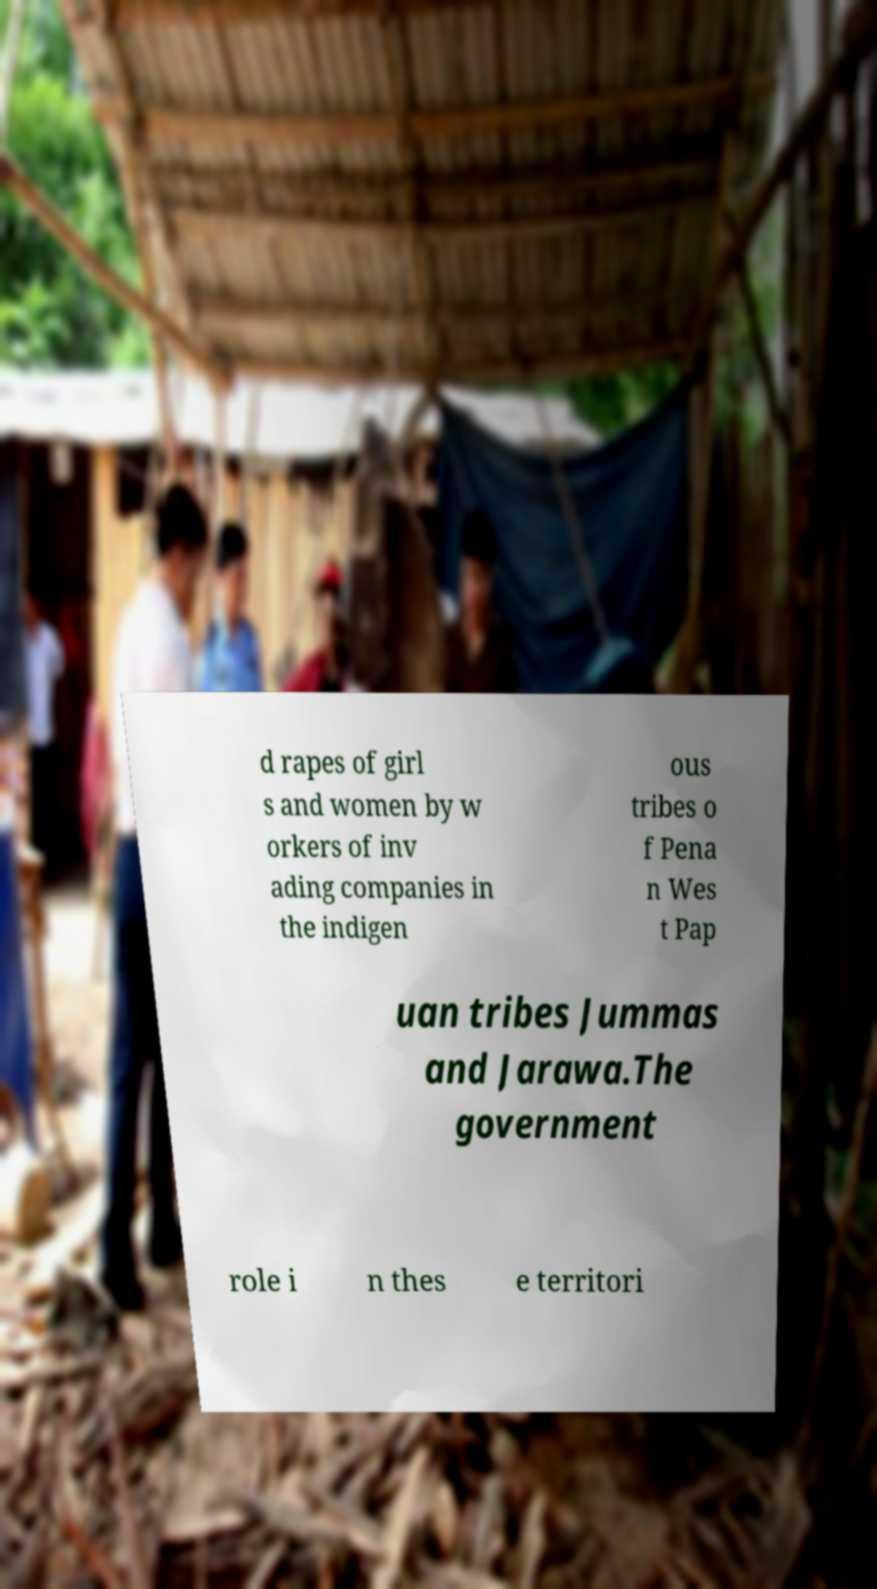Please read and relay the text visible in this image. What does it say? d rapes of girl s and women by w orkers of inv ading companies in the indigen ous tribes o f Pena n Wes t Pap uan tribes Jummas and Jarawa.The government role i n thes e territori 